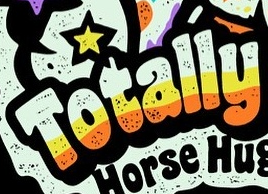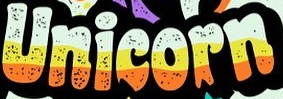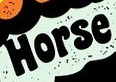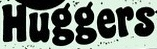Identify the words shown in these images in order, separated by a semicolon. Totally; Unicorn; Horse; Huggers 